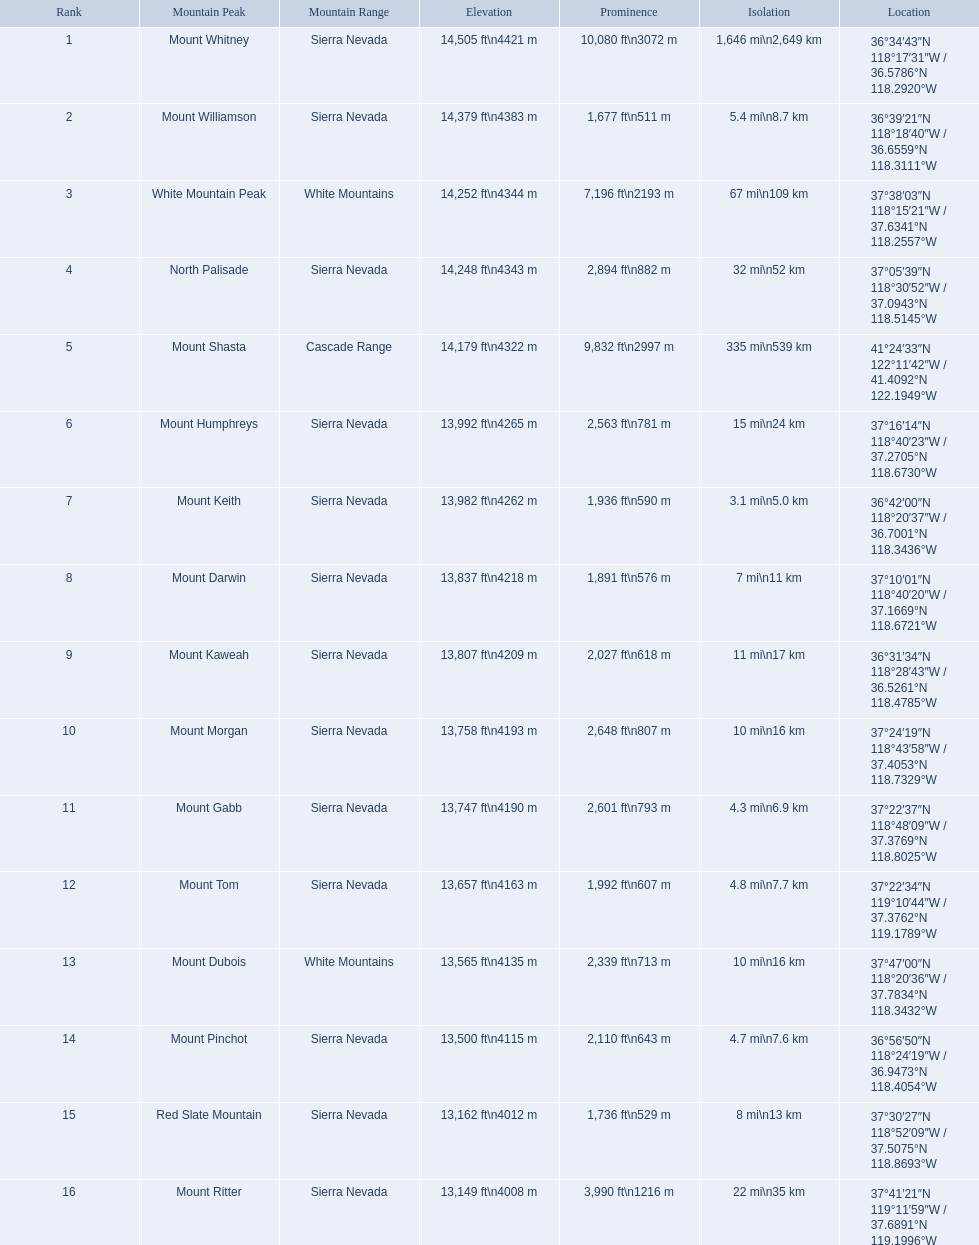What are all of the peaks? Mount Whitney, Mount Williamson, White Mountain Peak, North Palisade, Mount Shasta, Mount Humphreys, Mount Keith, Mount Darwin, Mount Kaweah, Mount Morgan, Mount Gabb, Mount Tom, Mount Dubois, Mount Pinchot, Red Slate Mountain, Mount Ritter. Where are they located? Sierra Nevada, Sierra Nevada, White Mountains, Sierra Nevada, Cascade Range, Sierra Nevada, Sierra Nevada, Sierra Nevada, Sierra Nevada, Sierra Nevada, Sierra Nevada, Sierra Nevada, White Mountains, Sierra Nevada, Sierra Nevada, Sierra Nevada. How tall are they? 14,505 ft\n4421 m, 14,379 ft\n4383 m, 14,252 ft\n4344 m, 14,248 ft\n4343 m, 14,179 ft\n4322 m, 13,992 ft\n4265 m, 13,982 ft\n4262 m, 13,837 ft\n4218 m, 13,807 ft\n4209 m, 13,758 ft\n4193 m, 13,747 ft\n4190 m, 13,657 ft\n4163 m, 13,565 ft\n4135 m, 13,500 ft\n4115 m, 13,162 ft\n4012 m, 13,149 ft\n4008 m. What about just the peaks in the sierra nevadas? 14,505 ft\n4421 m, 14,379 ft\n4383 m, 14,248 ft\n4343 m, 13,992 ft\n4265 m, 13,982 ft\n4262 m, 13,837 ft\n4218 m, 13,807 ft\n4209 m, 13,758 ft\n4193 m, 13,747 ft\n4190 m, 13,657 ft\n4163 m, 13,500 ft\n4115 m, 13,162 ft\n4012 m, 13,149 ft\n4008 m. And of those, which is the tallest? Mount Whitney. What are the highest points in california? Mount Whitney, Mount Williamson, White Mountain Peak, North Palisade, Mount Shasta, Mount Humphreys, Mount Keith, Mount Darwin, Mount Kaweah, Mount Morgan, Mount Gabb, Mount Tom, Mount Dubois, Mount Pinchot, Red Slate Mountain, Mount Ritter. What are the highest points in sierra nevada, california? Mount Whitney, Mount Williamson, North Palisade, Mount Humphreys, Mount Keith, Mount Darwin, Mount Kaweah, Mount Morgan, Mount Gabb, Mount Tom, Mount Pinchot, Red Slate Mountain, Mount Ritter. What are the elevations of the peaks in sierra nevada? 14,505 ft\n4421 m, 14,379 ft\n4383 m, 14,248 ft\n4343 m, 13,992 ft\n4265 m, 13,982 ft\n4262 m, 13,837 ft\n4218 m, 13,807 ft\n4209 m, 13,758 ft\n4193 m, 13,747 ft\n4190 m, 13,657 ft\n4163 m, 13,500 ft\n4115 m, 13,162 ft\n4012 m, 13,149 ft\n4008 m. Which one is the tallest? Mount Whitney. Which peak is mentioned for the sierra nevada mountain range? Mount Whitney. What peak has a height of 14,379 feet? Mount Williamson. What mountain is associated with the cascade range? Mount Shasta. 